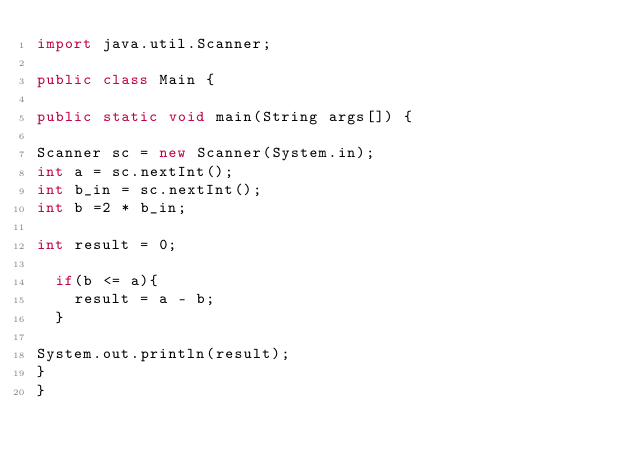Convert code to text. <code><loc_0><loc_0><loc_500><loc_500><_Java_>import java.util.Scanner;

public class Main {

public static void main(String args[]) {

Scanner sc = new Scanner(System.in);
int a = sc.nextInt();
int b_in = sc.nextInt();
int b =2 * b_in;
  
int result = 0;
  
  if(b <= a){
    result = a - b;
  }
  
System.out.println(result);
}
}
</code> 